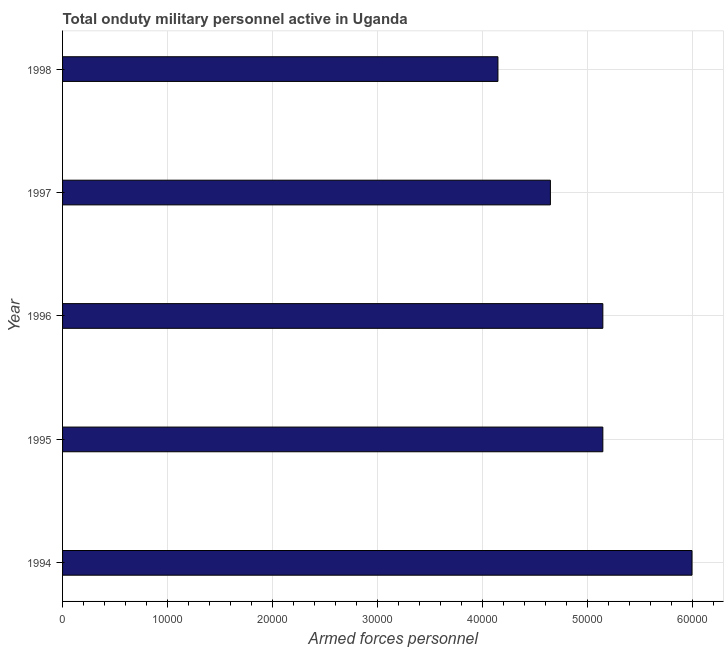Does the graph contain any zero values?
Offer a terse response. No. What is the title of the graph?
Provide a succinct answer. Total onduty military personnel active in Uganda. What is the label or title of the X-axis?
Make the answer very short. Armed forces personnel. What is the label or title of the Y-axis?
Ensure brevity in your answer.  Year. What is the number of armed forces personnel in 1995?
Give a very brief answer. 5.15e+04. Across all years, what is the minimum number of armed forces personnel?
Your answer should be compact. 4.15e+04. In which year was the number of armed forces personnel minimum?
Your answer should be very brief. 1998. What is the sum of the number of armed forces personnel?
Give a very brief answer. 2.51e+05. What is the difference between the number of armed forces personnel in 1995 and 1998?
Offer a very short reply. 10000. What is the average number of armed forces personnel per year?
Offer a terse response. 5.02e+04. What is the median number of armed forces personnel?
Offer a terse response. 5.15e+04. What is the ratio of the number of armed forces personnel in 1994 to that in 1995?
Offer a very short reply. 1.17. Is the number of armed forces personnel in 1995 less than that in 1997?
Your response must be concise. No. Is the difference between the number of armed forces personnel in 1994 and 1997 greater than the difference between any two years?
Your answer should be very brief. No. What is the difference between the highest and the second highest number of armed forces personnel?
Your answer should be compact. 8500. Is the sum of the number of armed forces personnel in 1997 and 1998 greater than the maximum number of armed forces personnel across all years?
Keep it short and to the point. Yes. What is the difference between the highest and the lowest number of armed forces personnel?
Provide a short and direct response. 1.85e+04. How many bars are there?
Make the answer very short. 5. What is the difference between two consecutive major ticks on the X-axis?
Your answer should be compact. 10000. What is the Armed forces personnel of 1994?
Give a very brief answer. 6.00e+04. What is the Armed forces personnel of 1995?
Provide a succinct answer. 5.15e+04. What is the Armed forces personnel in 1996?
Offer a very short reply. 5.15e+04. What is the Armed forces personnel of 1997?
Your response must be concise. 4.65e+04. What is the Armed forces personnel in 1998?
Ensure brevity in your answer.  4.15e+04. What is the difference between the Armed forces personnel in 1994 and 1995?
Your answer should be very brief. 8500. What is the difference between the Armed forces personnel in 1994 and 1996?
Your response must be concise. 8500. What is the difference between the Armed forces personnel in 1994 and 1997?
Offer a very short reply. 1.35e+04. What is the difference between the Armed forces personnel in 1994 and 1998?
Provide a succinct answer. 1.85e+04. What is the difference between the Armed forces personnel in 1995 and 1997?
Your response must be concise. 5000. What is the difference between the Armed forces personnel in 1995 and 1998?
Your response must be concise. 10000. What is the difference between the Armed forces personnel in 1996 and 1997?
Your answer should be compact. 5000. What is the ratio of the Armed forces personnel in 1994 to that in 1995?
Keep it short and to the point. 1.17. What is the ratio of the Armed forces personnel in 1994 to that in 1996?
Keep it short and to the point. 1.17. What is the ratio of the Armed forces personnel in 1994 to that in 1997?
Keep it short and to the point. 1.29. What is the ratio of the Armed forces personnel in 1994 to that in 1998?
Make the answer very short. 1.45. What is the ratio of the Armed forces personnel in 1995 to that in 1997?
Offer a very short reply. 1.11. What is the ratio of the Armed forces personnel in 1995 to that in 1998?
Offer a very short reply. 1.24. What is the ratio of the Armed forces personnel in 1996 to that in 1997?
Keep it short and to the point. 1.11. What is the ratio of the Armed forces personnel in 1996 to that in 1998?
Make the answer very short. 1.24. What is the ratio of the Armed forces personnel in 1997 to that in 1998?
Make the answer very short. 1.12. 